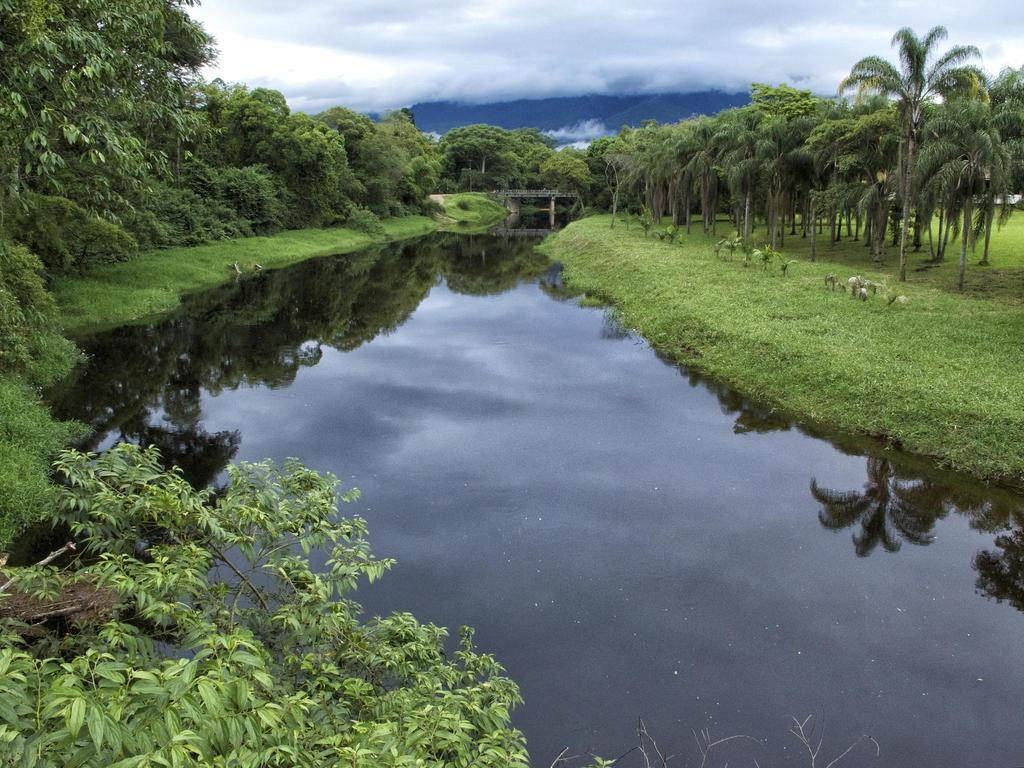What is the main feature in the center of the image? There is a canal in the center of the image. What can be seen in the background of the image? There is a bridge and trees in the background of the image. What is visible at the top of the image? The sky is visible at the top of the image. Can you tell me how many gallons of milk are flowing through the canal in the image? There is no milk present in the image; it is a canal with water. What type of paint is being used to create the bridge in the image? There is no paint visible in the image; the bridge is a solid structure. 